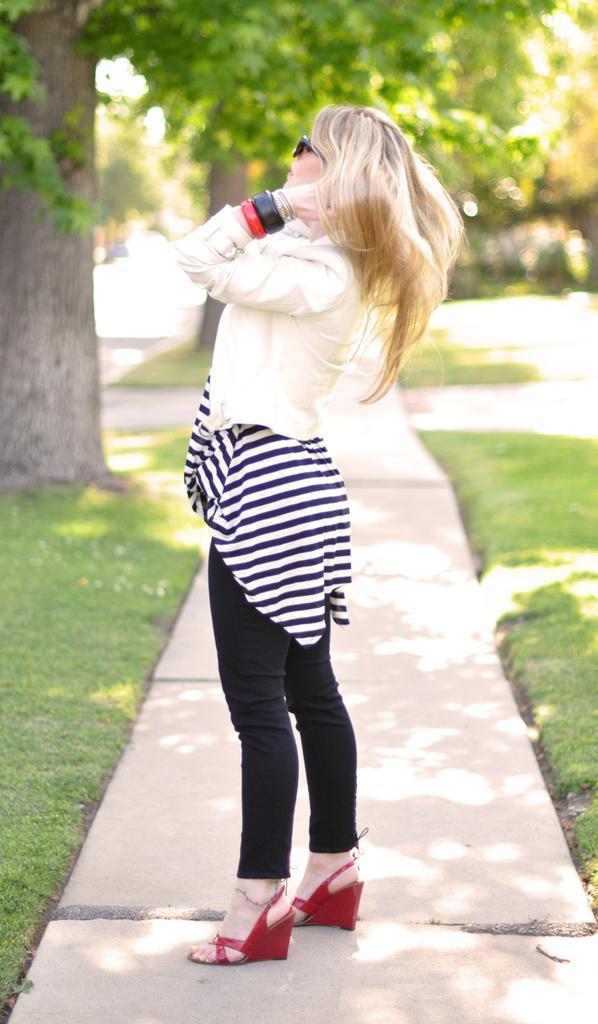Please provide a concise description of this image. In this image I can see a woman is standing and she wore white color top, black color trouser. On the left side there are trees. 